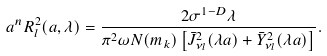<formula> <loc_0><loc_0><loc_500><loc_500>a ^ { n } R _ { l } ^ { 2 } ( a , \lambda ) = \frac { 2 \sigma ^ { 1 - D } \lambda } { \pi ^ { 2 } \omega N ( m _ { k } ) \left [ \bar { J } _ { \nu _ { l } } ^ { 2 } ( \lambda a ) + \bar { Y } _ { \nu _ { l } } ^ { 2 } ( \lambda a ) \right ] } .</formula> 